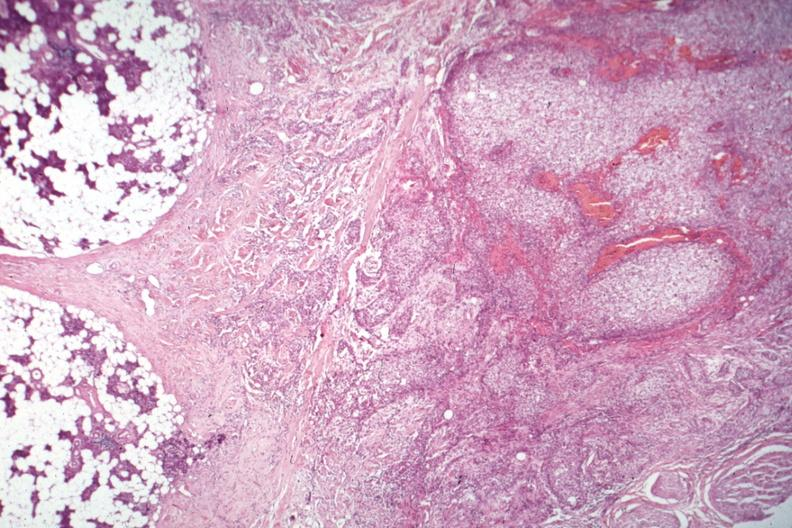s abdomen present?
Answer the question using a single word or phrase. No 